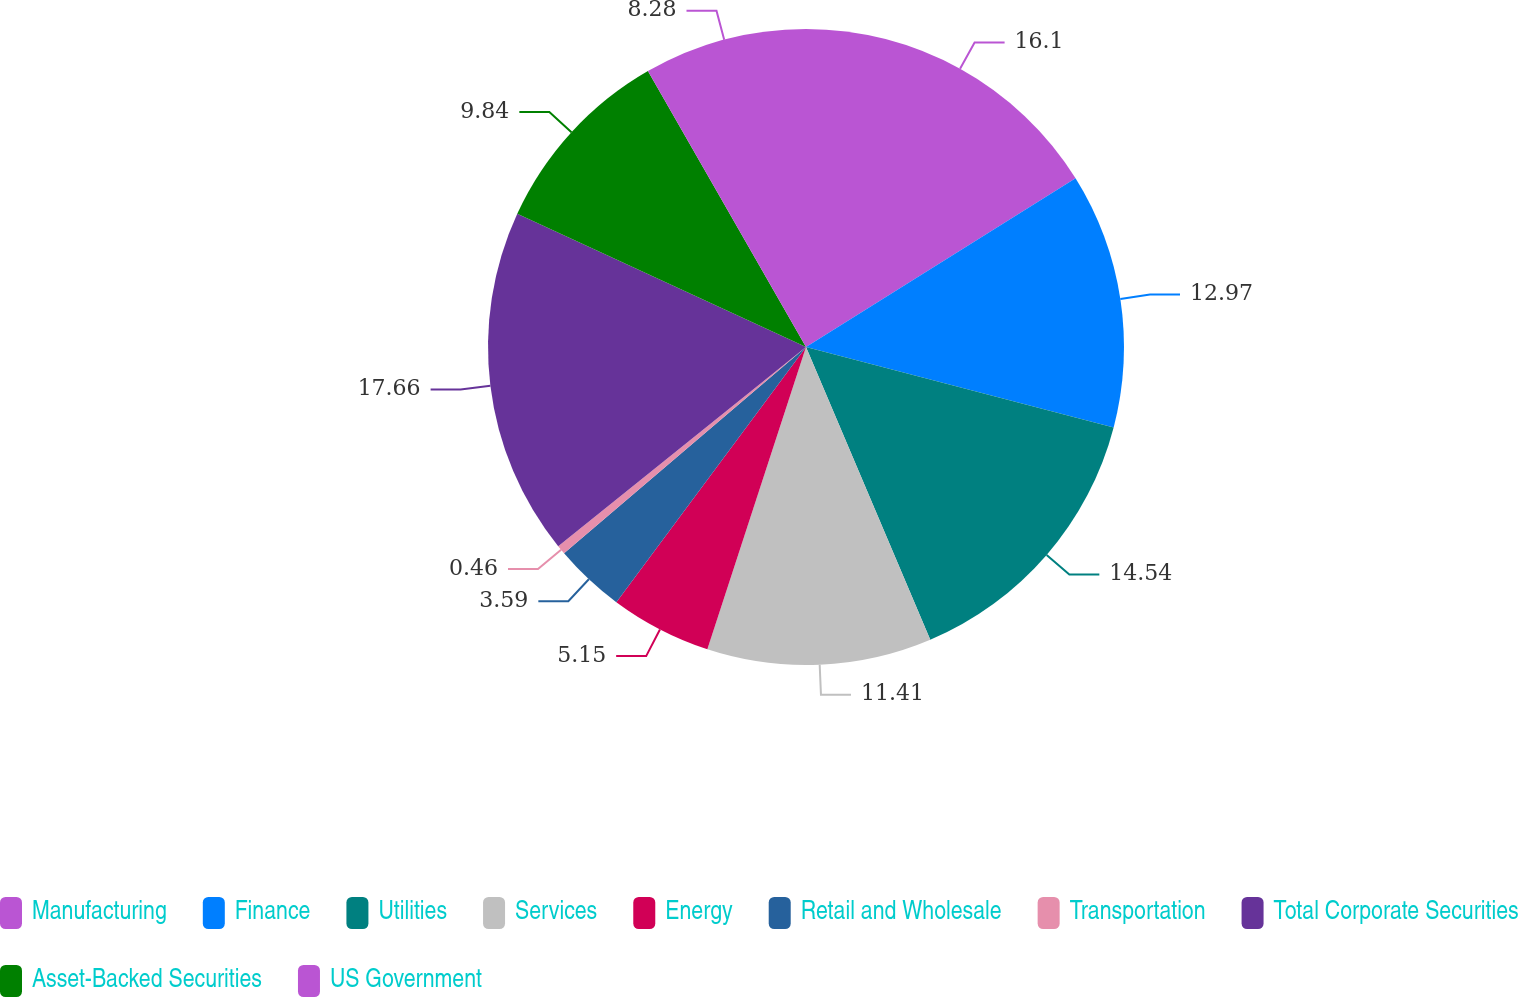<chart> <loc_0><loc_0><loc_500><loc_500><pie_chart><fcel>Manufacturing<fcel>Finance<fcel>Utilities<fcel>Services<fcel>Energy<fcel>Retail and Wholesale<fcel>Transportation<fcel>Total Corporate Securities<fcel>Asset-Backed Securities<fcel>US Government<nl><fcel>16.1%<fcel>12.97%<fcel>14.54%<fcel>11.41%<fcel>5.15%<fcel>3.59%<fcel>0.46%<fcel>17.66%<fcel>9.84%<fcel>8.28%<nl></chart> 